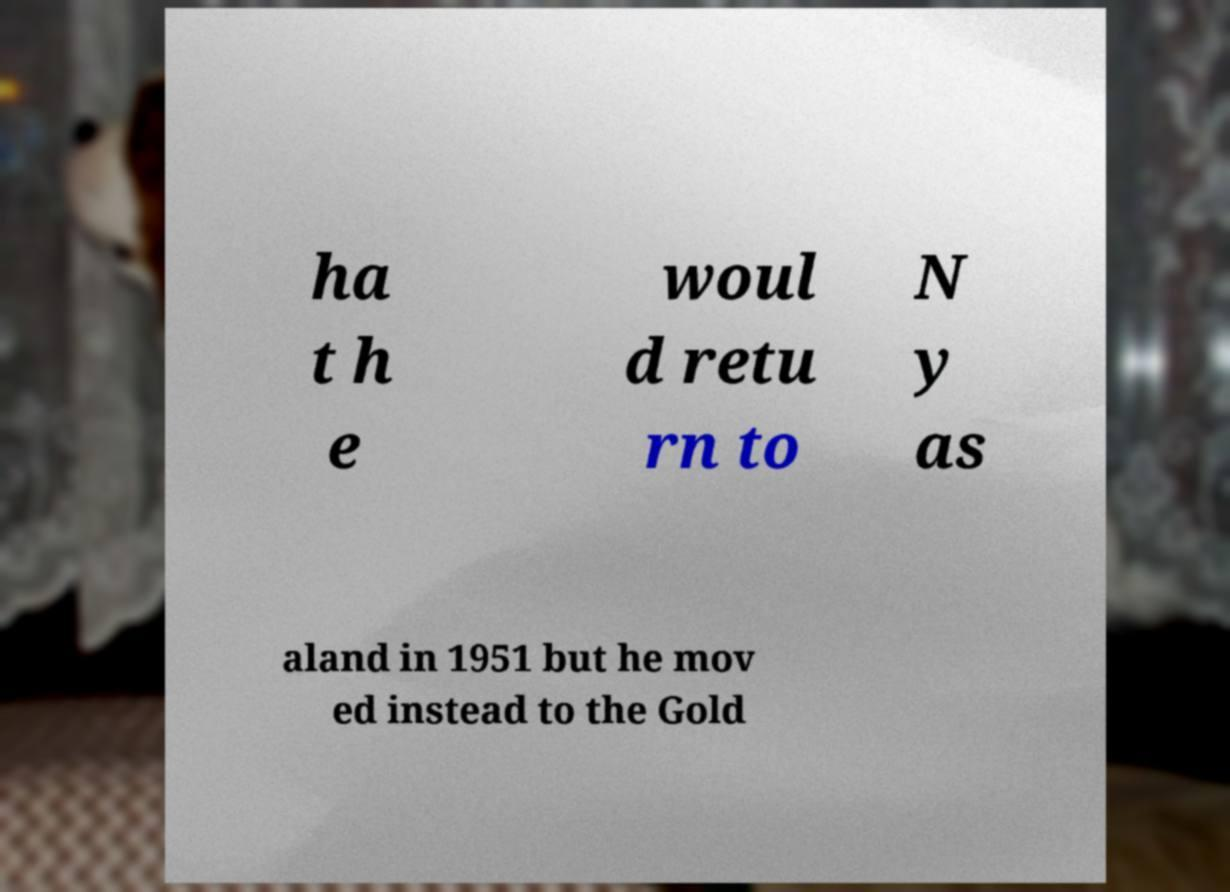I need the written content from this picture converted into text. Can you do that? ha t h e woul d retu rn to N y as aland in 1951 but he mov ed instead to the Gold 